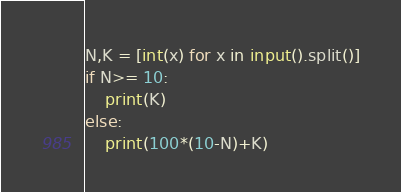Convert code to text. <code><loc_0><loc_0><loc_500><loc_500><_Python_>N,K = [int(x) for x in input().split()]
if N>= 10:
    print(K)
else:
    print(100*(10-N)+K)</code> 